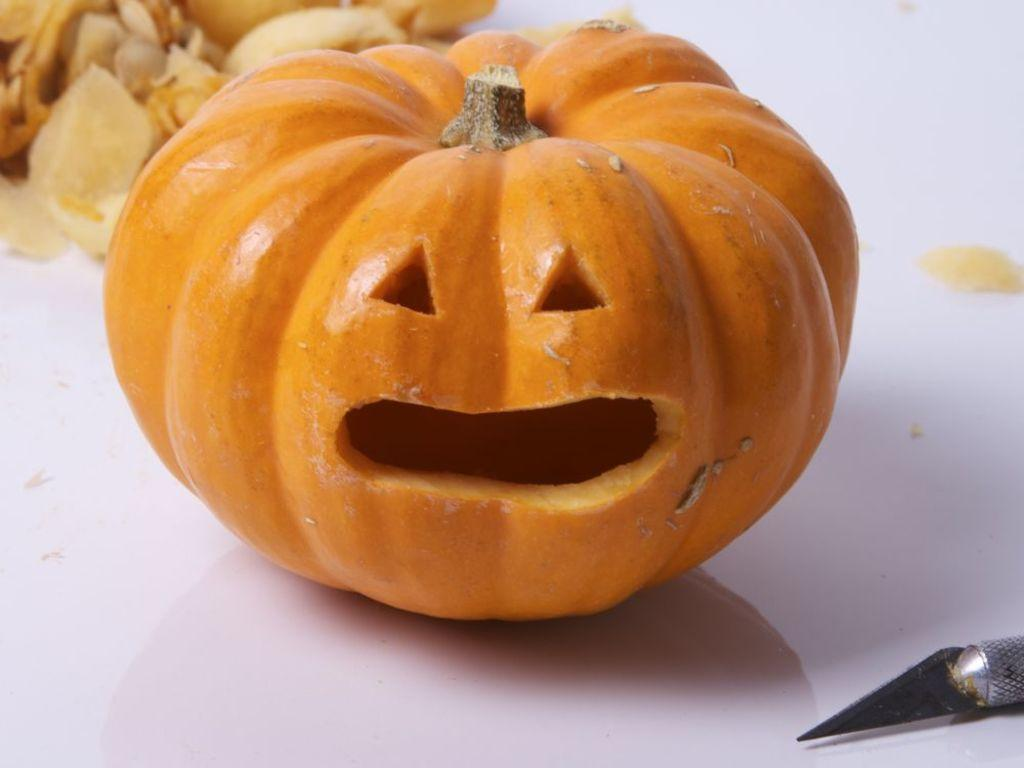What is the main object in the image? There is a pumpkin in the image. What other object can be seen in the image? There is a pen knife in the image. Where are the pumpkin and pen knife located? The pumpkin and pen knife are placed on a surface. How many ants are crawling on the pumpkin in the image? There are no ants present in the image; it only features a pumpkin and a pen knife. What type of zebra can be seen in the image? There is no zebra present in the image. 